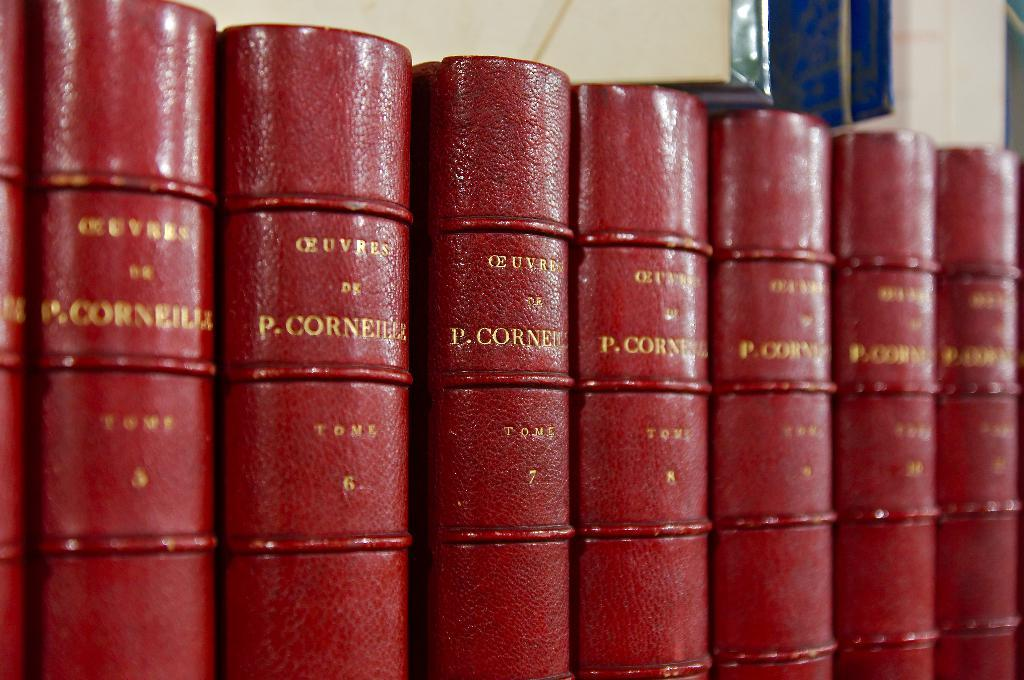<image>
Give a short and clear explanation of the subsequent image. A row of books all written by P. Corneilez 